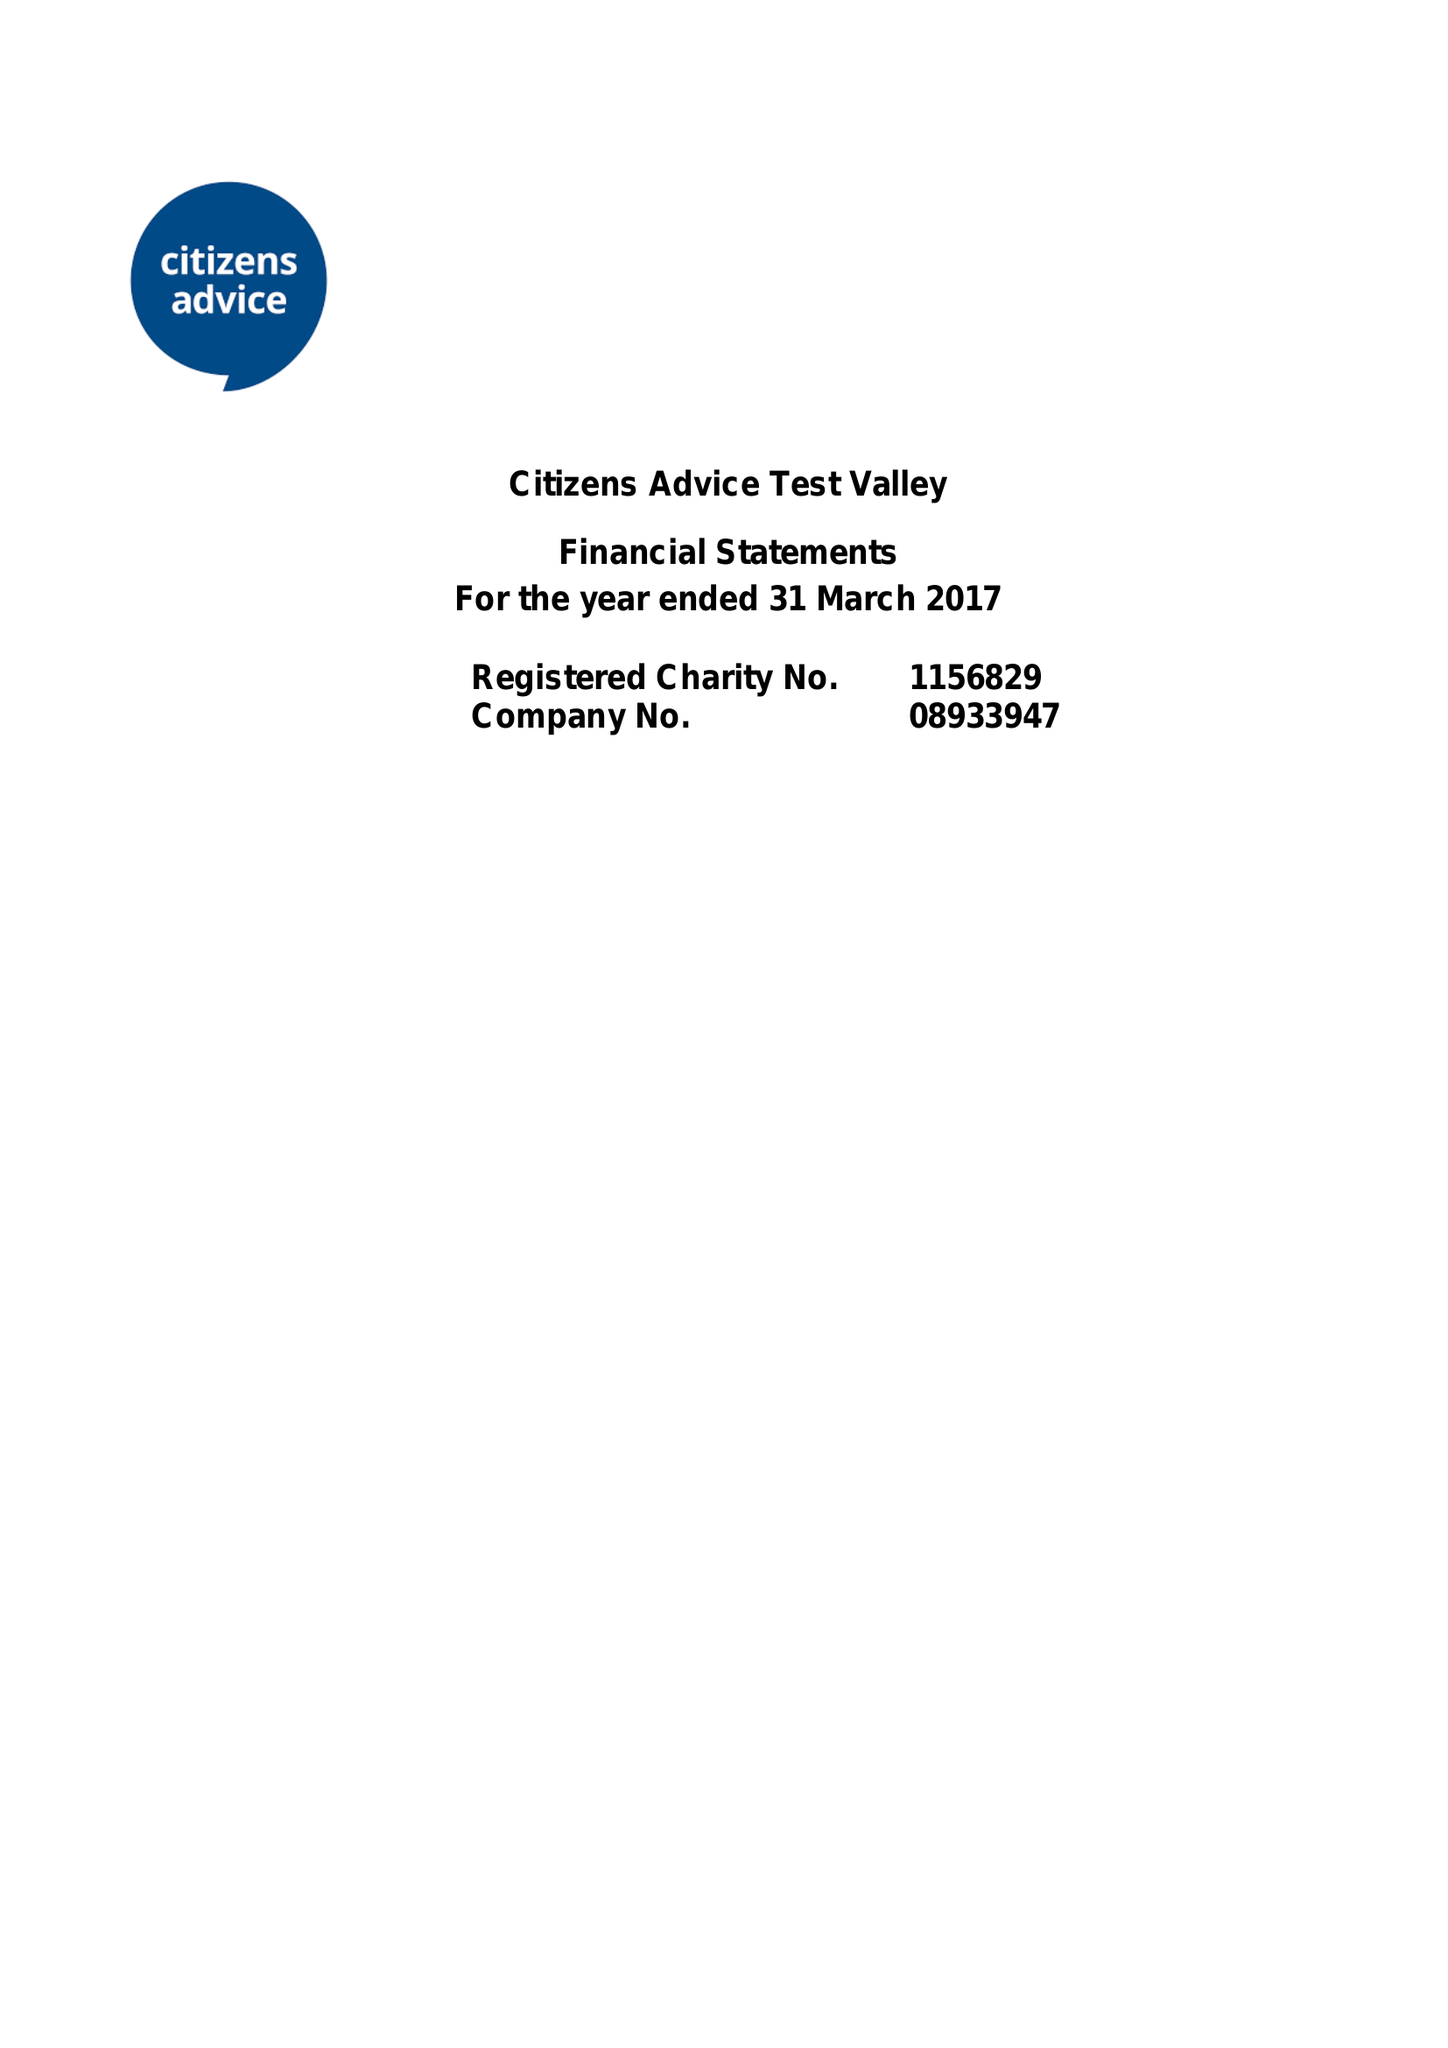What is the value for the income_annually_in_british_pounds?
Answer the question using a single word or phrase. 284289.00 